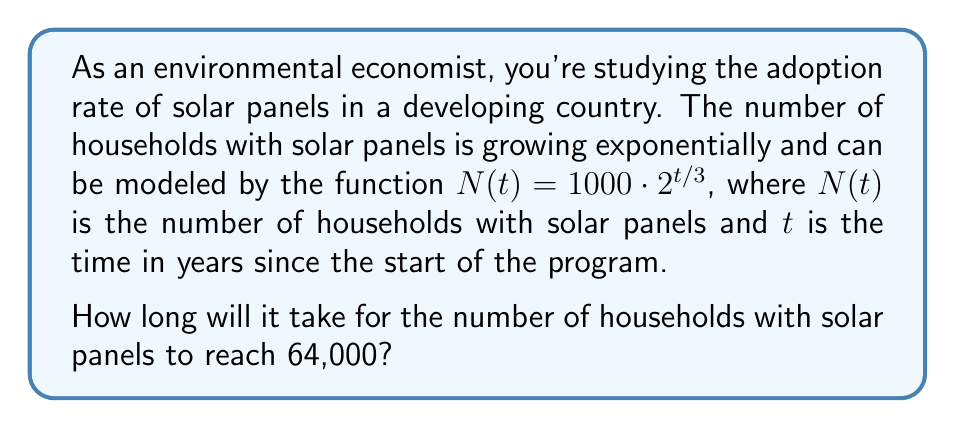Help me with this question. Let's approach this step-by-step:

1) We need to solve the equation:
   $64000 = 1000 \cdot 2^{t/3}$

2) Divide both sides by 1000:
   $64 = 2^{t/3}$

3) Take the logarithm (base 2) of both sides:
   $\log_2(64) = \log_2(2^{t/3})$

4) Simplify the left side:
   $6 = t/3$

   Note: $\log_2(64) = 6$ because $2^6 = 64$

5) Multiply both sides by 3:
   $18 = t$

This solution demonstrates the power of logarithms in solving exponential equations, which are common in modeling renewable energy adoption and other environmental phenomena.
Answer: It will take 18 years for the number of households with solar panels to reach 64,000. 